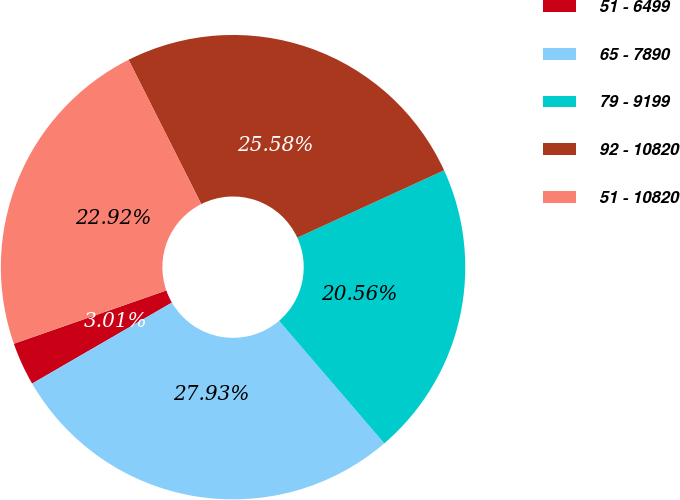<chart> <loc_0><loc_0><loc_500><loc_500><pie_chart><fcel>51 - 6499<fcel>65 - 7890<fcel>79 - 9199<fcel>92 - 10820<fcel>51 - 10820<nl><fcel>3.01%<fcel>27.93%<fcel>20.56%<fcel>25.58%<fcel>22.92%<nl></chart> 